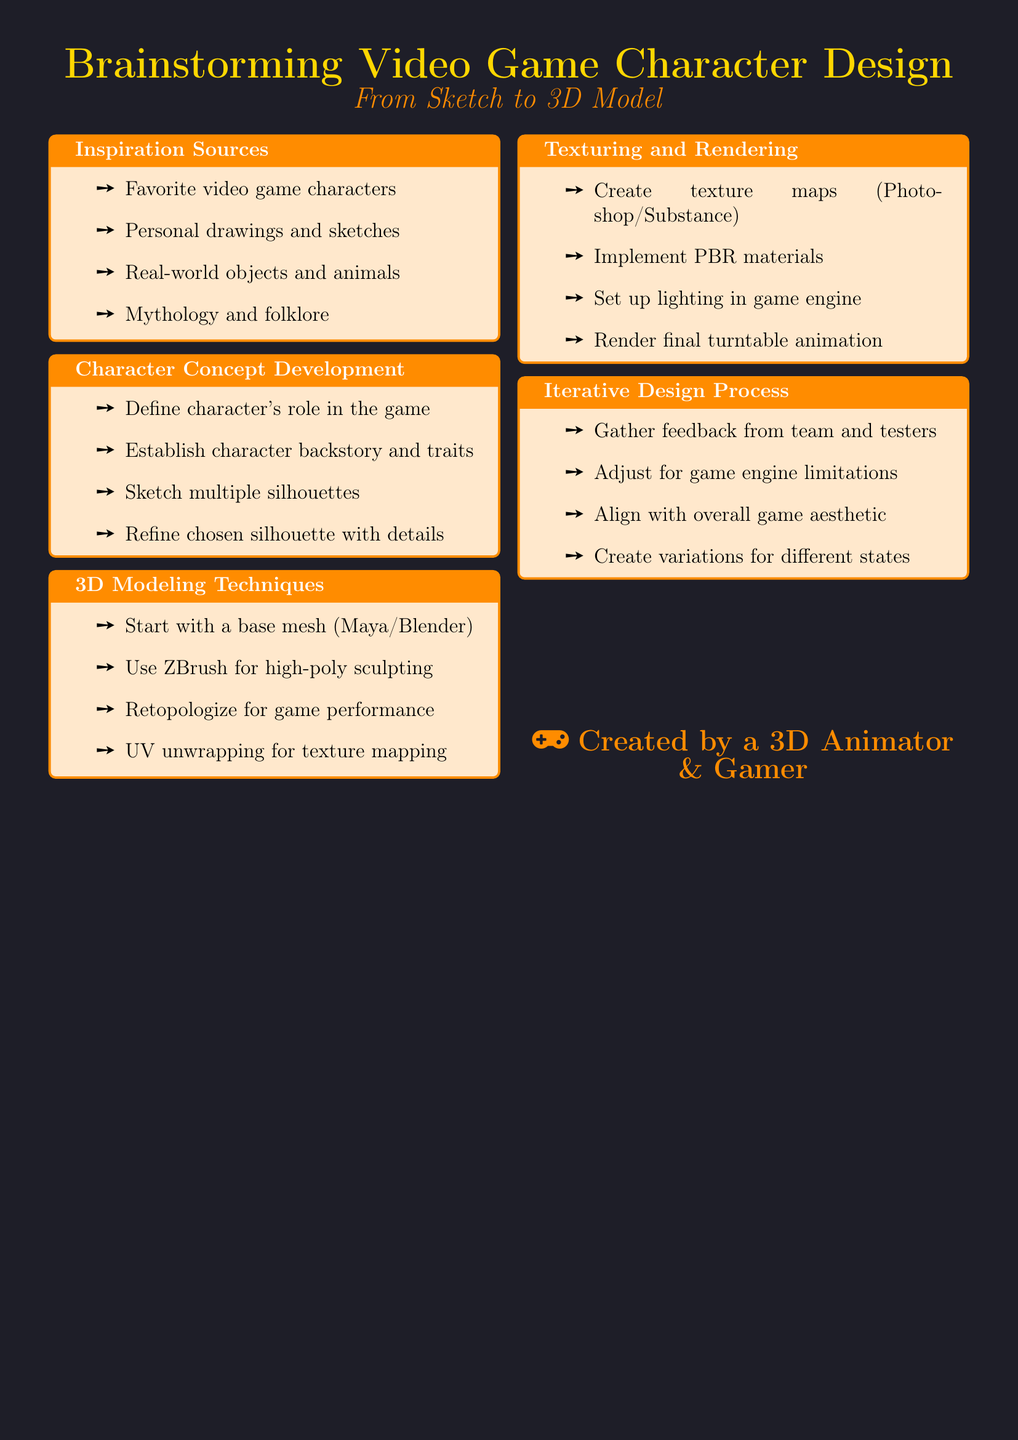what are some inspiration sources for character design? The inspiration sources include favorite video game characters, personal drawings and sketches, real-world objects and animals, and mythology and folklore.
Answer: Favorite video game characters, personal drawings, real-world objects, mythology what software is mentioned for creating texture maps? The document lists Adobe Photoshop and Substance Painter for creating texture maps.
Answer: Adobe Photoshop, Substance Painter what is the first step in character concept development? The first step in character concept development is to define the character's role in the game.
Answer: Define character's role how many sections are in the document? The document contains five sections: Inspiration Sources, Character Concept Development, 3D Modeling Techniques, Texturing and Rendering, and Iterative Design Process.
Answer: Five which technique is used for high-poly sculpting? The document mentions using ZBrush for high-poly sculpting and detailing.
Answer: ZBrush what is the purpose of retopologizing in 3D modeling? Retopologizing is done for optimal game performance as stated in the 3D modeling techniques.
Answer: Optimal game performance what is the final step mentioned in the texturing and rendering section? The final step mentioned is to render a final turntable animation for presentation.
Answer: Render final turntable animation what should be adjusted based on game engine limitations? Adjustments should be made to the character design based on game engine limitations.
Answer: Character design what role does feedback play in the iterative design process? Feedback from team members and playtesters helps in making adjustments during the iterative design process.
Answer: Gather feedback 